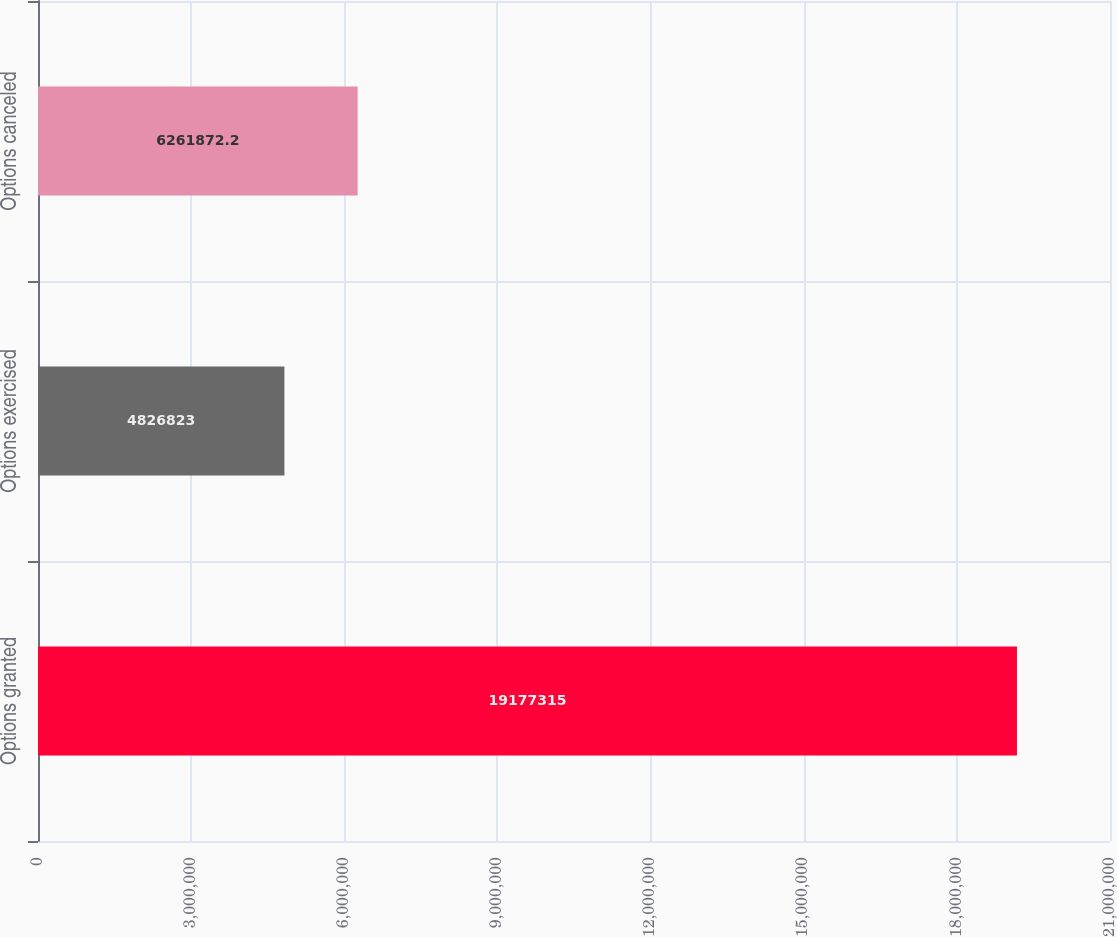<chart> <loc_0><loc_0><loc_500><loc_500><bar_chart><fcel>Options granted<fcel>Options exercised<fcel>Options canceled<nl><fcel>1.91773e+07<fcel>4.82682e+06<fcel>6.26187e+06<nl></chart> 